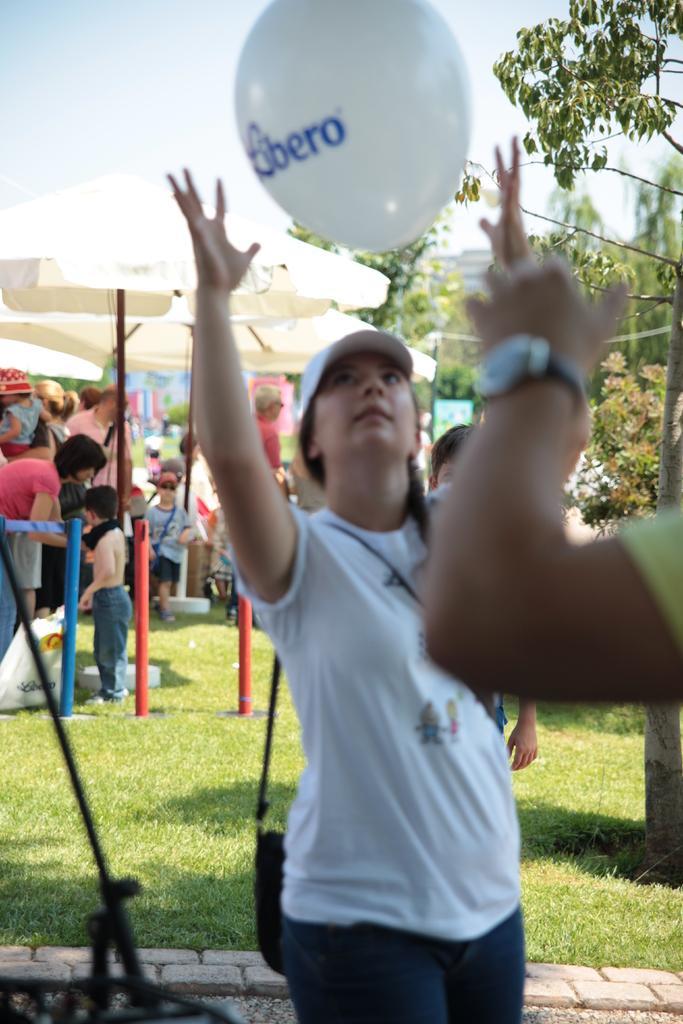How would you summarize this image in a sentence or two? In the image there is a park and some events are going on in that park, there is a woman standing in the front and trying to catch a balloon and behind her there are many other people and on the right side there are few trees. 